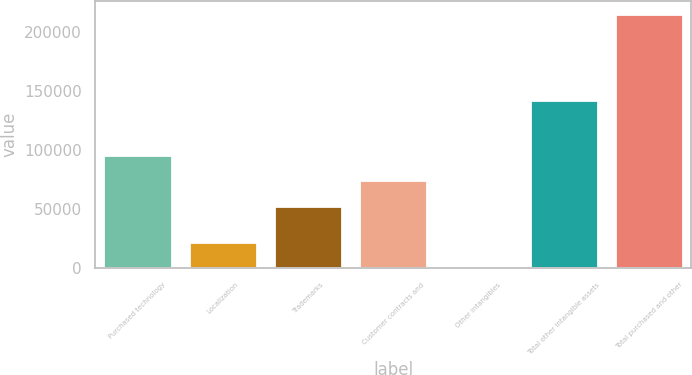<chart> <loc_0><loc_0><loc_500><loc_500><bar_chart><fcel>Purchased technology<fcel>Localization<fcel>Trademarks<fcel>Customer contracts and<fcel>Other intangibles<fcel>Total other intangible assets<fcel>Total purchased and other<nl><fcel>95646<fcel>21901<fcel>52744<fcel>74195<fcel>450<fcel>142160<fcel>214960<nl></chart> 